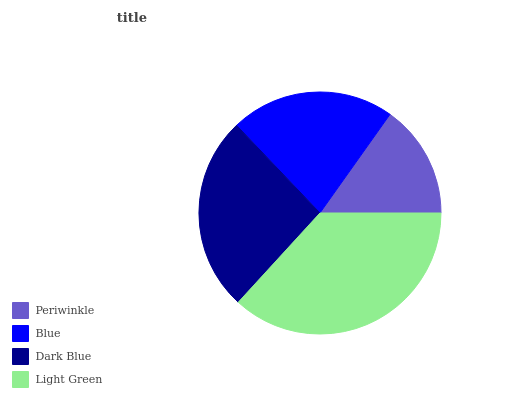Is Periwinkle the minimum?
Answer yes or no. Yes. Is Light Green the maximum?
Answer yes or no. Yes. Is Blue the minimum?
Answer yes or no. No. Is Blue the maximum?
Answer yes or no. No. Is Blue greater than Periwinkle?
Answer yes or no. Yes. Is Periwinkle less than Blue?
Answer yes or no. Yes. Is Periwinkle greater than Blue?
Answer yes or no. No. Is Blue less than Periwinkle?
Answer yes or no. No. Is Dark Blue the high median?
Answer yes or no. Yes. Is Blue the low median?
Answer yes or no. Yes. Is Light Green the high median?
Answer yes or no. No. Is Dark Blue the low median?
Answer yes or no. No. 